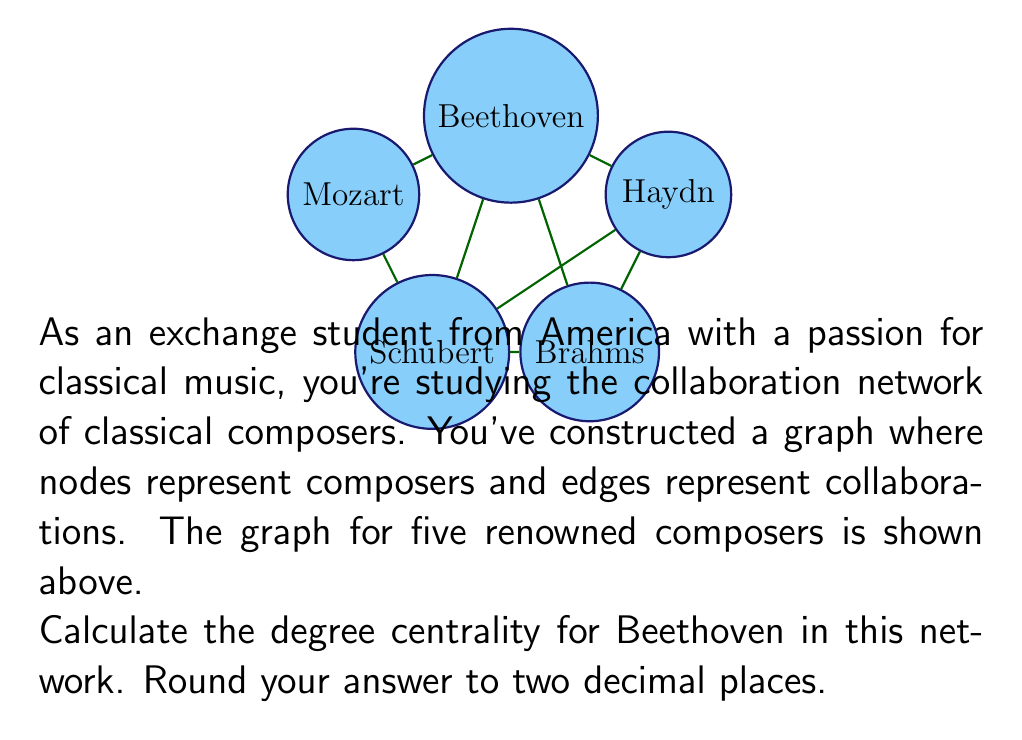Provide a solution to this math problem. To solve this problem, we'll follow these steps:

1) Understand degree centrality:
   Degree centrality is a measure of the number of direct connections a node has in a network.

2) Calculate the degree of Beethoven:
   From the graph, we can see that Beethoven (node B) is directly connected to:
   - Mozart
   - Haydn
   - Schubert
   - Brahms
   So, Beethoven's degree is 4.

3) Calculate the maximum possible degree:
   In a network with n nodes, the maximum possible degree is n-1.
   Here, we have 5 nodes, so the maximum possible degree is 5-1 = 4.

4) Calculate degree centrality:
   The formula for degree centrality is:
   
   $$C_D(v) = \frac{degree(v)}{n-1}$$
   
   where $v$ is the node, and $n$ is the total number of nodes.

5) Plug in the values:
   $$C_D(Beethoven) = \frac{4}{5-1} = \frac{4}{4} = 1$$

6) Round to two decimal places:
   1.00

Therefore, Beethoven's degree centrality in this network is 1.00.
Answer: 1.00 